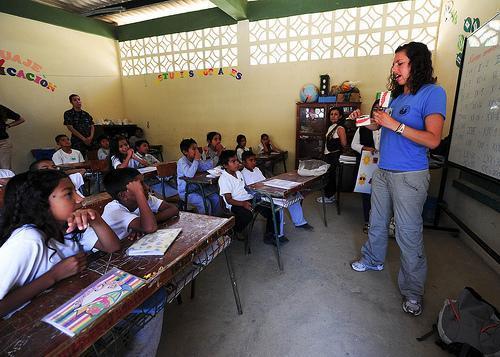How many people are standing?
Give a very brief answer. 4. How many kids are sitting in the front row?
Give a very brief answer. 4. 